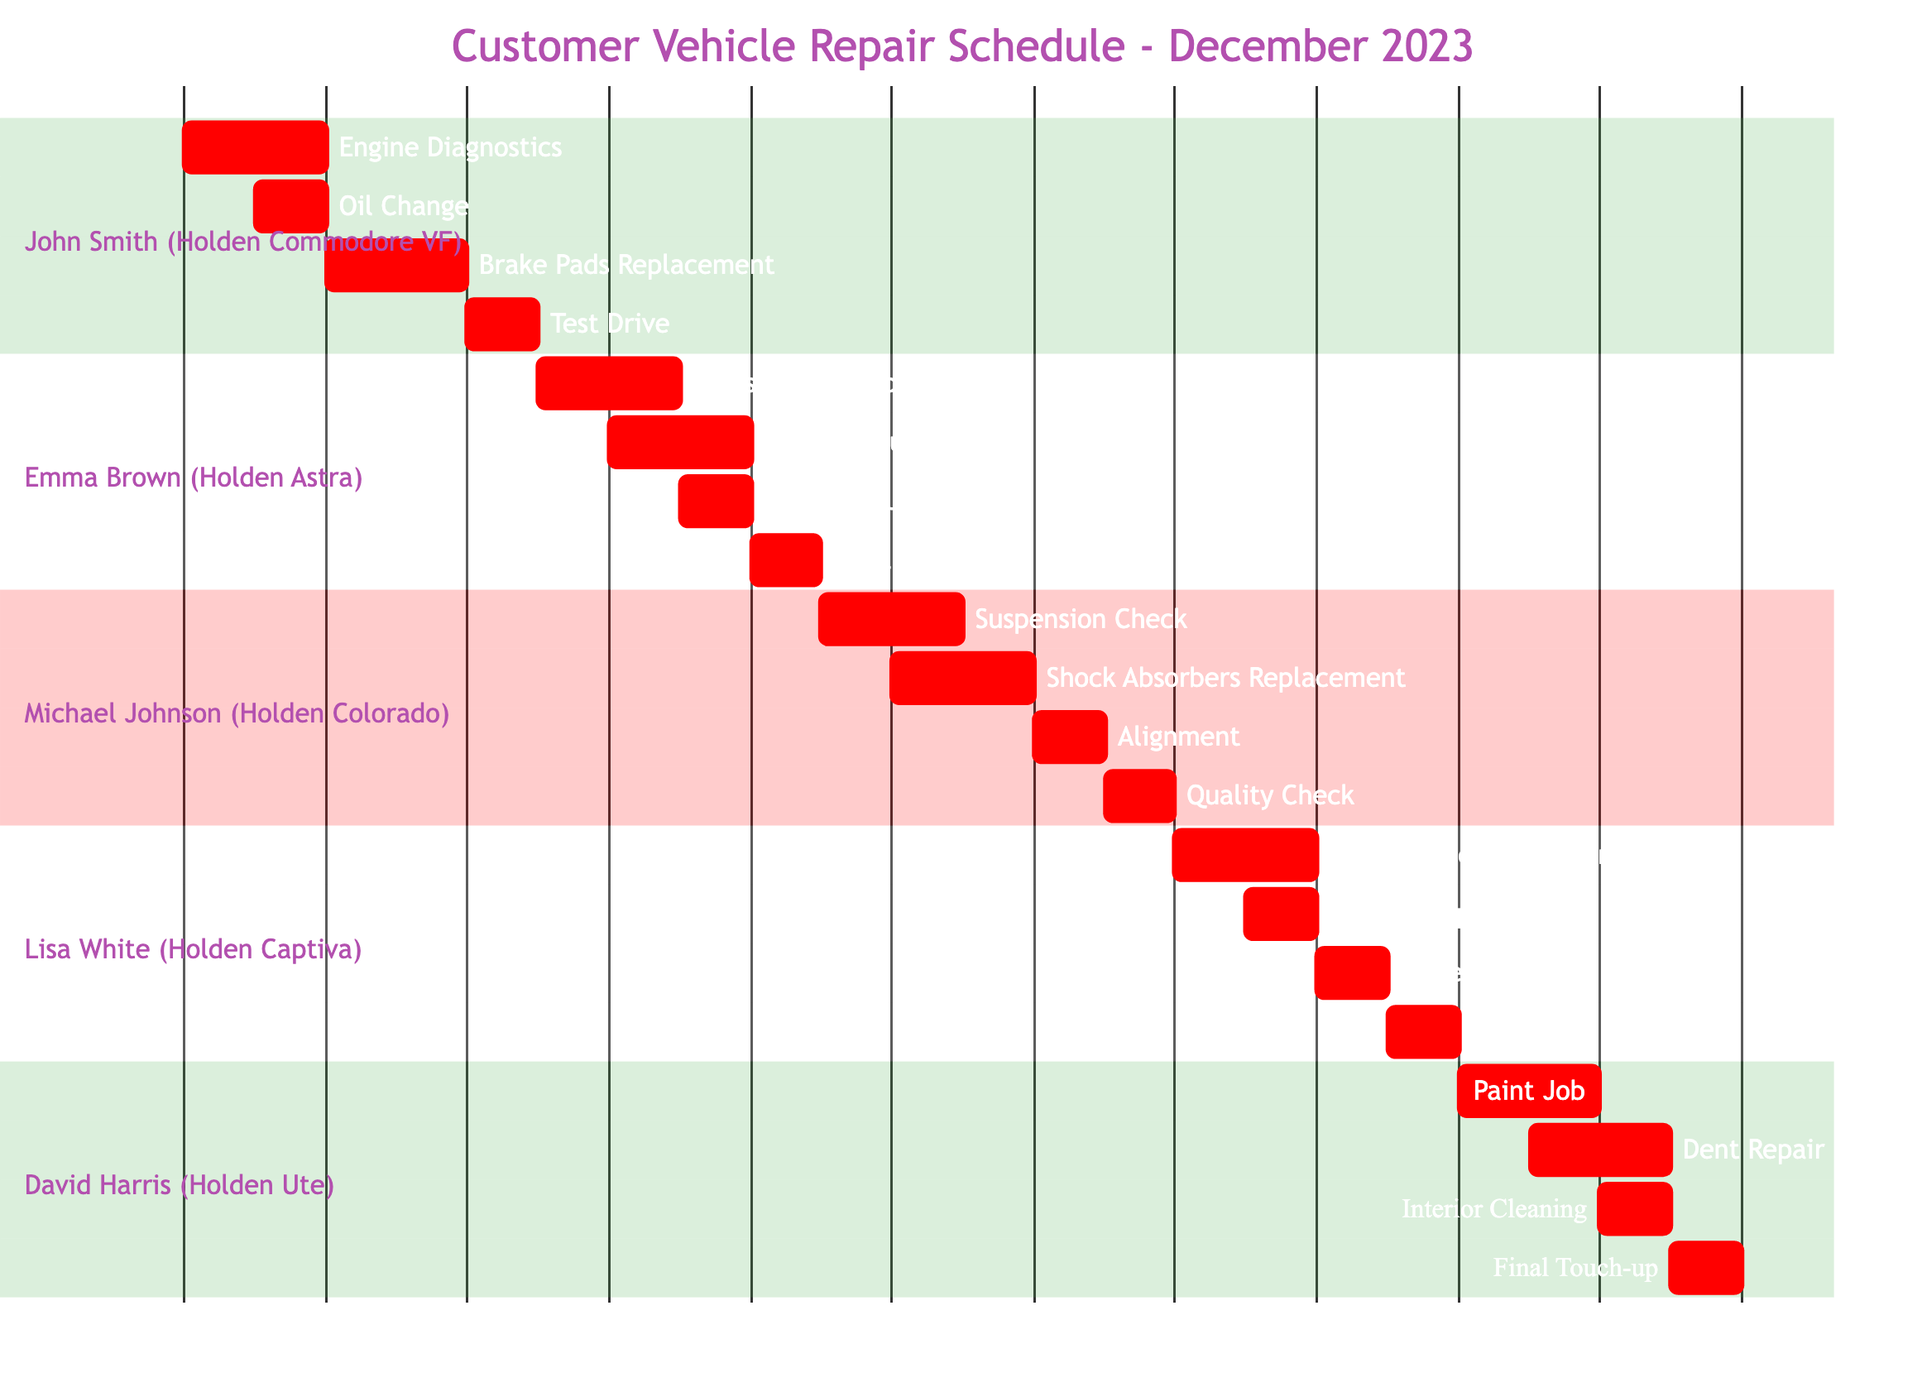What is the duration of the repair for John Smith's vehicle? The repair for John Smith's Holden Commodore VF starts on December 1, 2023, and ends on December 5, 2023. The duration is calculated as 5 days from the start to the end date.
Answer: 5 days Which vehicle model is scheduled for repair on December 8, 2023? On December 8, 2023, the tasks scheduled are for Emma Brown's Holden Astra, specifically the Fluid Top-Up task. This is determined by checking the detailed timeline of tasks.
Answer: Holden Astra How many tasks are planned for David Harris's vehicle repair? David Harris's Holden Ute has 4 tasks planned in total: Paint Job, Dent Repair, Interior Cleaning, and Final Touch-up. This can be counted in the section dedicated to David Harris.
Answer: 4 tasks What is the last task scheduled for Michael Johnson's vehicle? The final task for Michael Johnson's Holden Colorado is Quality Check, which is scheduled for December 14, 2023. By examining the tasks in Michael's section, it is identified as the last one on the timeline.
Answer: Quality Check Which task starts immediately after the Oil Change in John Smith's schedule? After the Oil Change task, which occurs on December 2, 2023, the next task is Brake Pads Replacement, starting on December 3, 2023. This is realized by analyzing the sequence of tasks.
Answer: Brake Pads Replacement Which customer has their repair schedule start on December 15, 2023? The customer whose repair schedule starts on December 15, 2023, is Lisa White, for her Holden Captiva. This date can be found directly in the schedule under Lisa's section.
Answer: Lisa White How long does the repair last for Emma Brown's vehicle? Emma Brown's Holden Astra repair lasts 4 days, from December 6, 2023, to December 9, 2023. This is calculated by subtracting the start date from the end date.
Answer: 4 days What is the purpose of the task scheduled on December 22, 2023, for David Harris? The task scheduled on December 22, 2023, for David Harris is the Final Touch-up. This is confirmed by checking David's task timeline.
Answer: Final Touch-up Which task for Lisa White's vehicle occurs on the same day as the Battery Replacement? The task that occurs on the same day as the Battery Replacement on December 16, 2023, is Air Conditioning Repair, which starts on the same day. This is derived from reviewing the schedule for overlaps in dates.
Answer: Air Conditioning Repair 